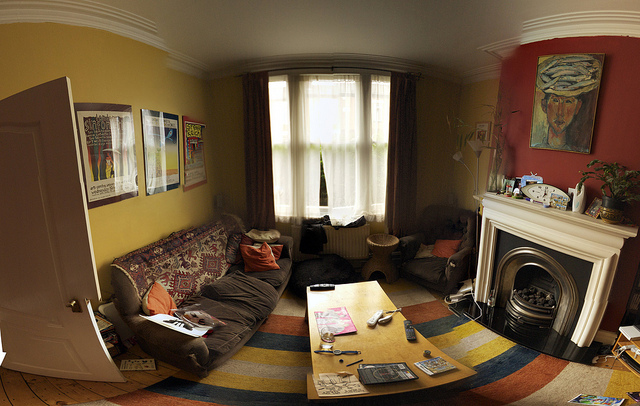<image>What is the reflective object in the fireplace? I don't know what the reflective object in the fireplace is. It can be a mirror, grill, guard, metal, wood, frame, or coal. How much does the sofa weigh? It is unknown how much does the sofa weigh. How much does the sofa weigh? It is unknown how much the sofa weighs. What is the reflective object in the fireplace? I don't know what the reflective object in the fireplace is. It can be seen as a mirror, grill, guard, metal, or wood. 